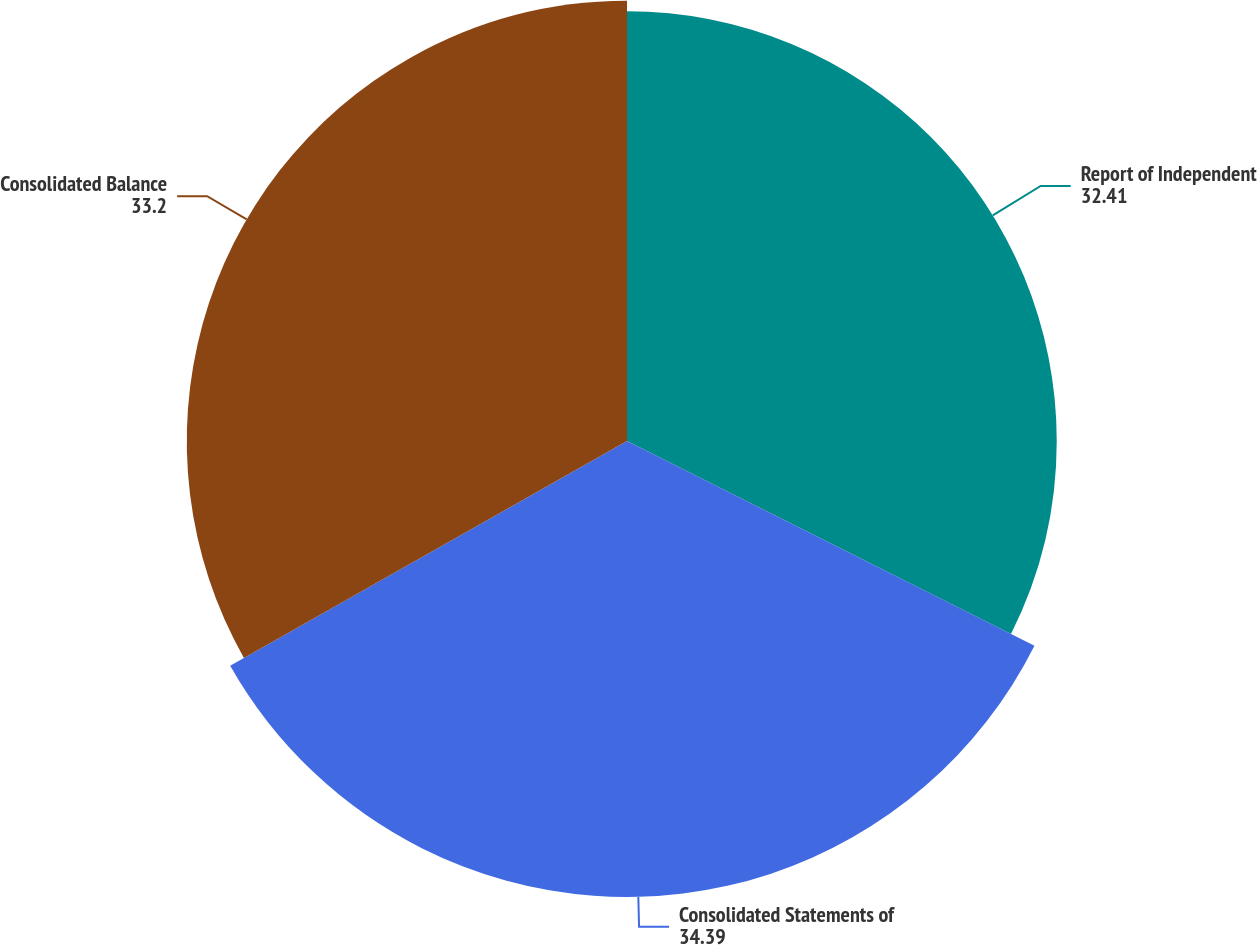Convert chart. <chart><loc_0><loc_0><loc_500><loc_500><pie_chart><fcel>Report of Independent<fcel>Consolidated Statements of<fcel>Consolidated Balance<nl><fcel>32.41%<fcel>34.39%<fcel>33.2%<nl></chart> 